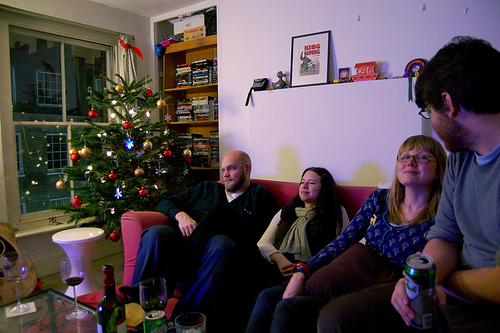<image>
Is there a window behind the can? No. The window is not behind the can. From this viewpoint, the window appears to be positioned elsewhere in the scene. Where is the lady in relation to the lady? Is it on the lady? No. The lady is not positioned on the lady. They may be near each other, but the lady is not supported by or resting on top of the lady. 